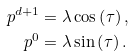Convert formula to latex. <formula><loc_0><loc_0><loc_500><loc_500>p ^ { d + 1 } & = \lambda \cos \left ( \tau \right ) , \\ p ^ { 0 } & = \lambda \sin \left ( \tau \right ) .</formula> 